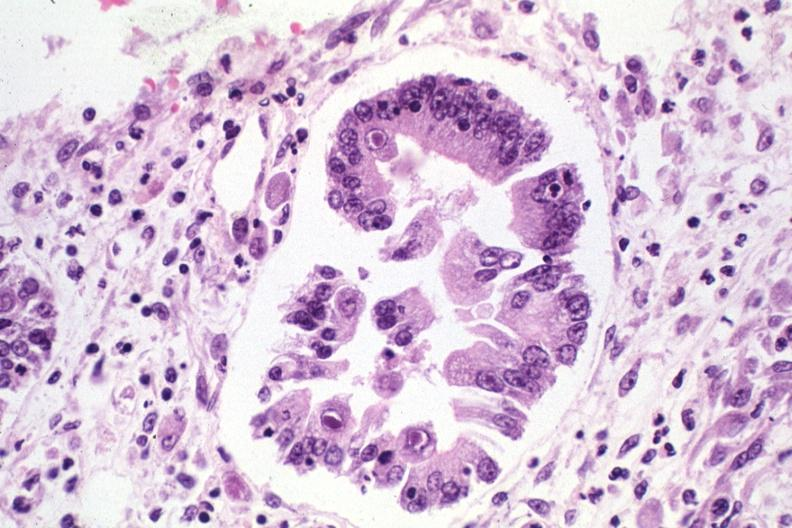s acute lymphocytic leukemia present?
Answer the question using a single word or phrase. No 